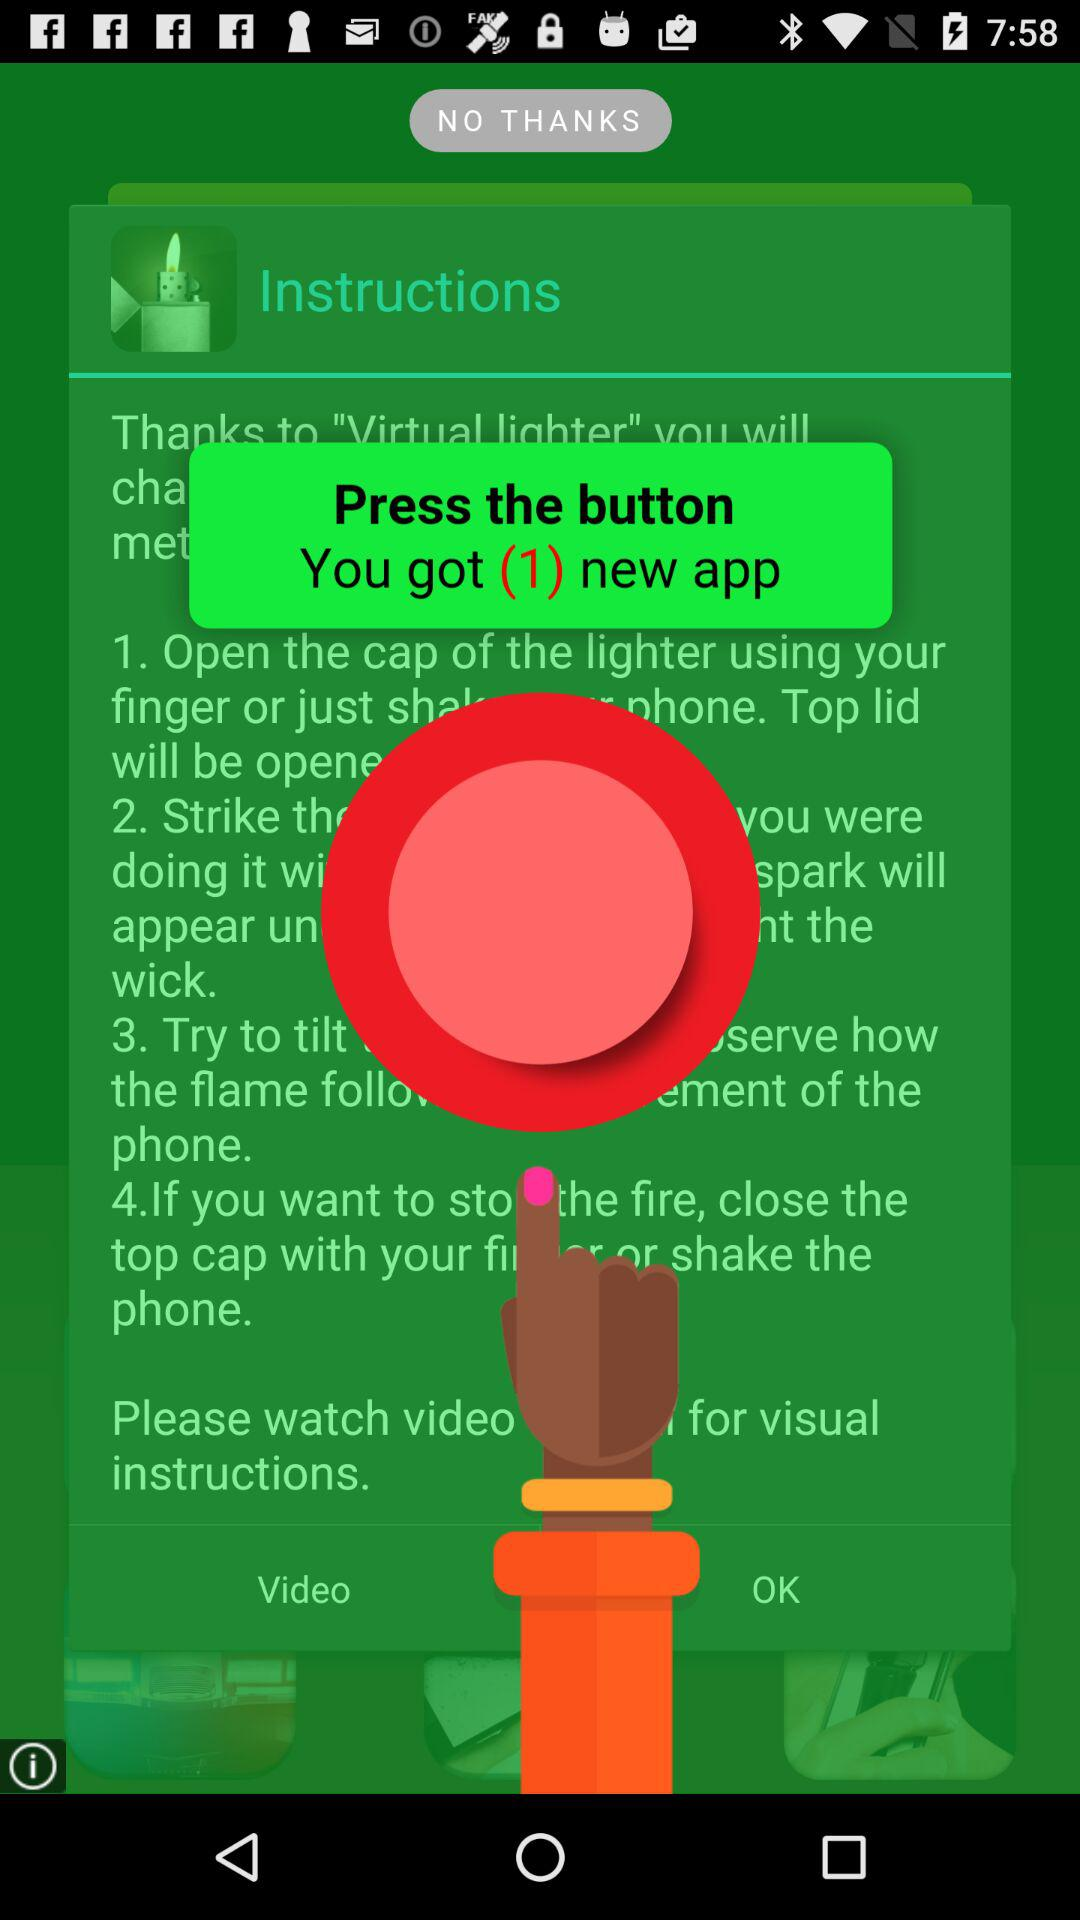How many instructions are there for using the virtual lighter?
Answer the question using a single word or phrase. 4 